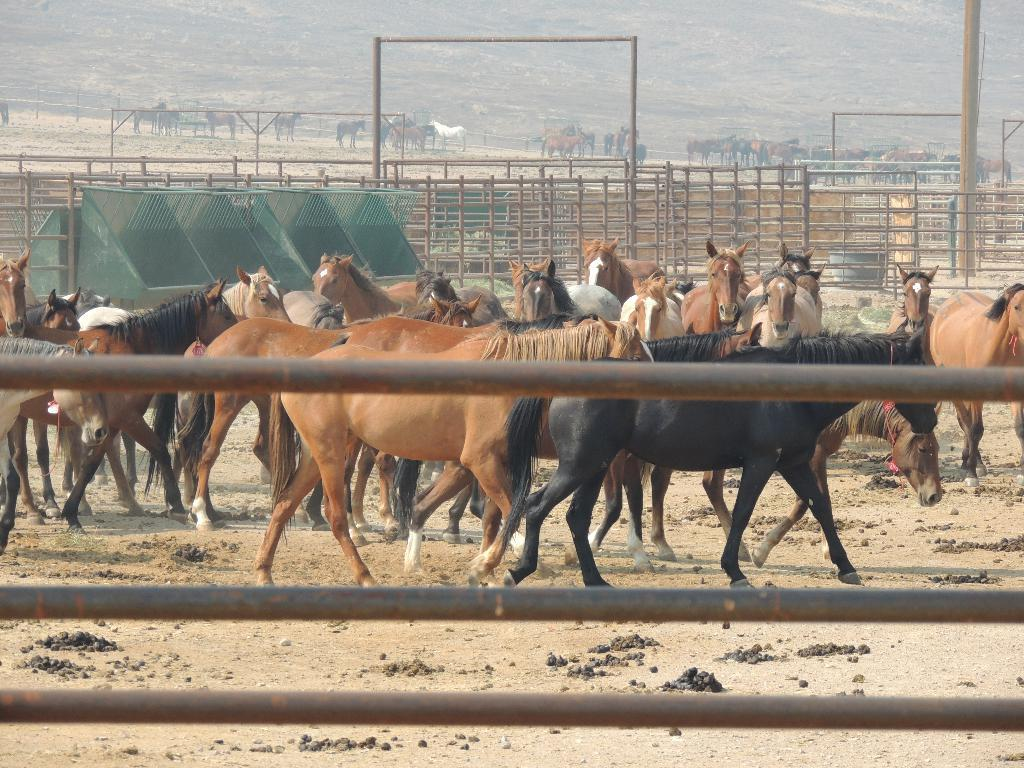What animals are present in the image? There are many horses in the image. Can you describe the horses in the image? The horses are of different colors. What is the purpose of the fence in the image? The fence is likely used to contain or separate the horses. What are the poles in the image used for? The poles may be used for marking a course or guiding the horses. How would you describe the background of the image? The background is slightly foggy. What type of cork can be seen floating in the vessel in the image? There is no cork or vessel present in the image; it features horses and a slightly foggy background. 